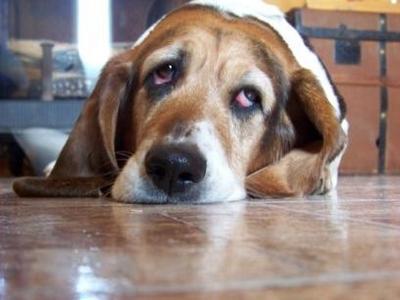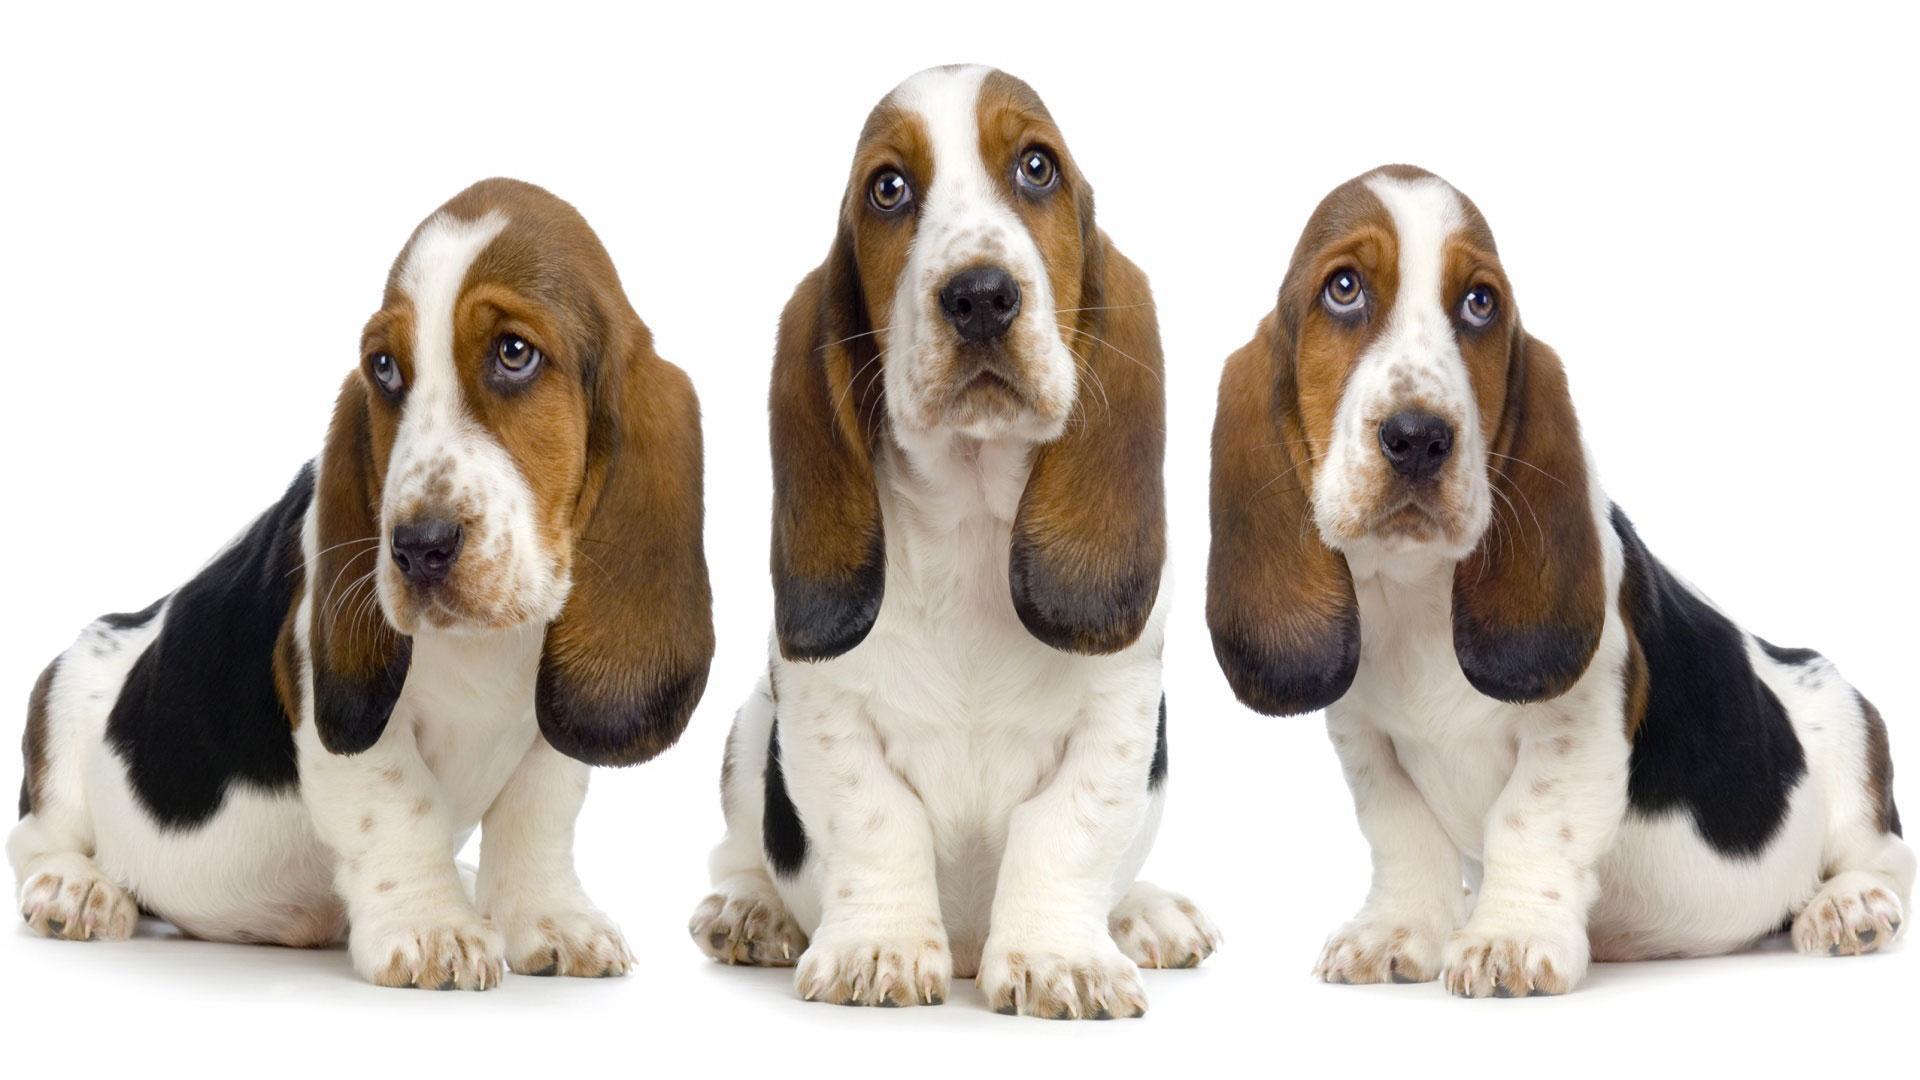The first image is the image on the left, the second image is the image on the right. Assess this claim about the two images: "The dog in the image on the right is outside.". Correct or not? Answer yes or no. No. 